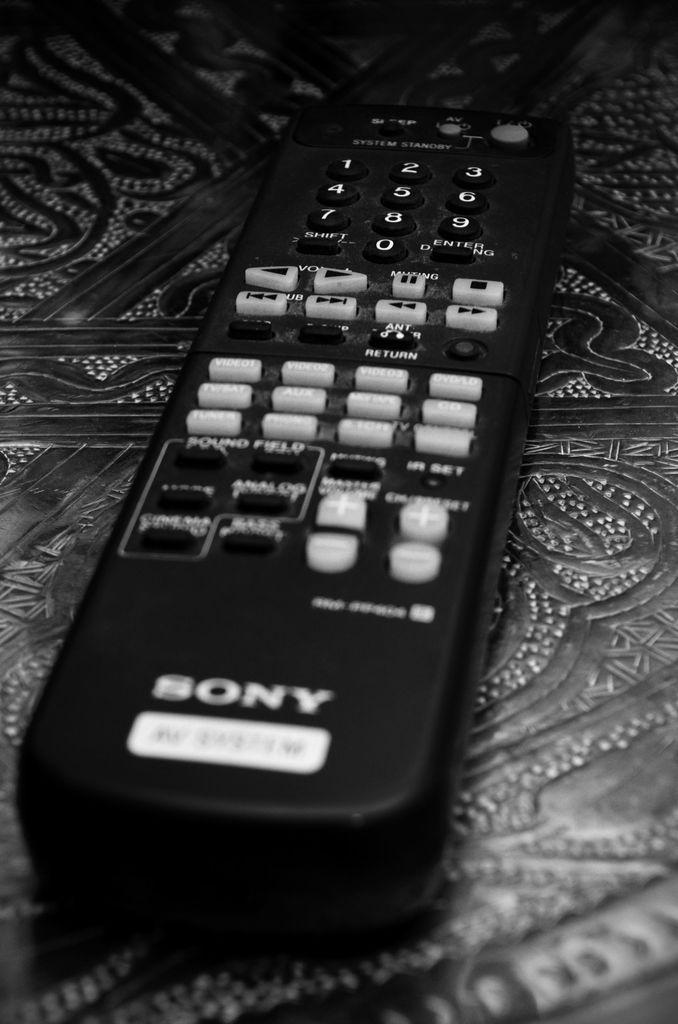Provide a one-sentence caption for the provided image. A close up of a black Sony remote control. 